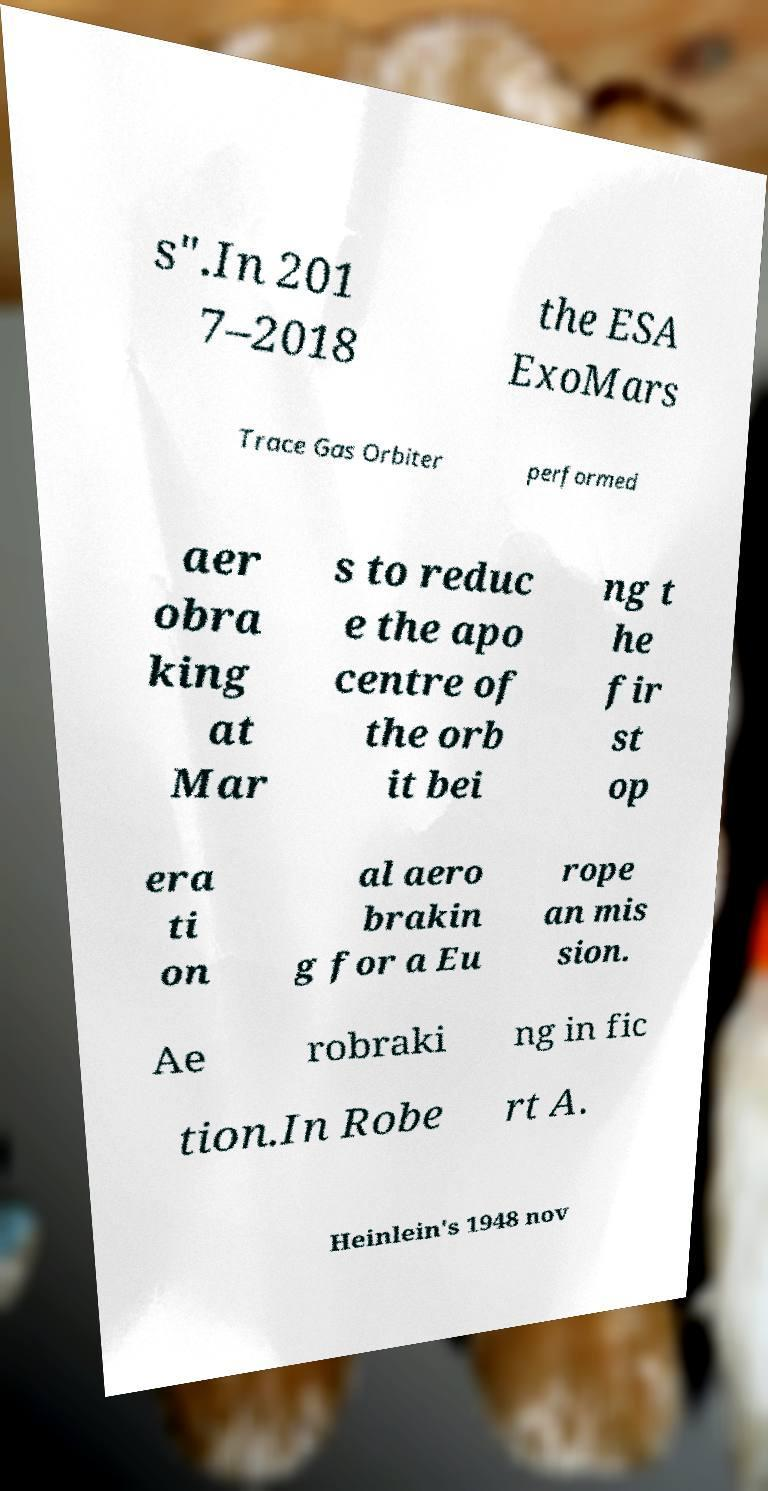I need the written content from this picture converted into text. Can you do that? s".In 201 7–2018 the ESA ExoMars Trace Gas Orbiter performed aer obra king at Mar s to reduc e the apo centre of the orb it bei ng t he fir st op era ti on al aero brakin g for a Eu rope an mis sion. Ae robraki ng in fic tion.In Robe rt A. Heinlein's 1948 nov 